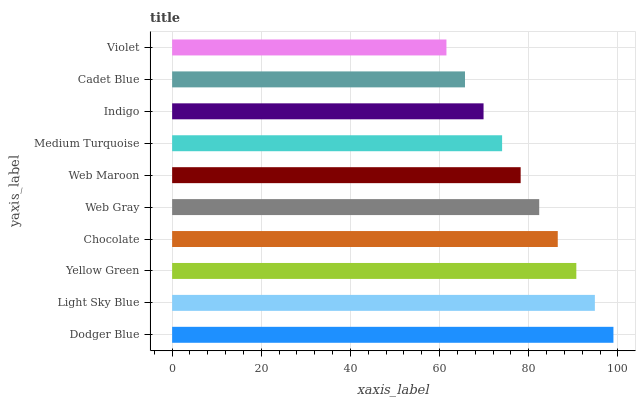Is Violet the minimum?
Answer yes or no. Yes. Is Dodger Blue the maximum?
Answer yes or no. Yes. Is Light Sky Blue the minimum?
Answer yes or no. No. Is Light Sky Blue the maximum?
Answer yes or no. No. Is Dodger Blue greater than Light Sky Blue?
Answer yes or no. Yes. Is Light Sky Blue less than Dodger Blue?
Answer yes or no. Yes. Is Light Sky Blue greater than Dodger Blue?
Answer yes or no. No. Is Dodger Blue less than Light Sky Blue?
Answer yes or no. No. Is Web Gray the high median?
Answer yes or no. Yes. Is Web Maroon the low median?
Answer yes or no. Yes. Is Chocolate the high median?
Answer yes or no. No. Is Light Sky Blue the low median?
Answer yes or no. No. 